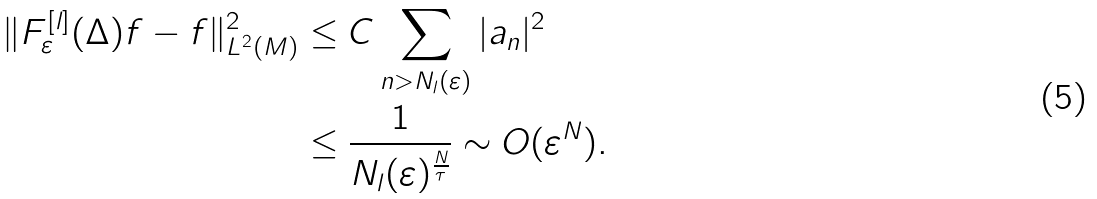<formula> <loc_0><loc_0><loc_500><loc_500>\| F ^ { [ l ] } _ { \varepsilon } ( \Delta ) f - f \| _ { L ^ { 2 } ( M ) } ^ { 2 } & \leq C \sum _ { n > N _ { l } ( \varepsilon ) } | a _ { n } | ^ { 2 } \\ & \leq \frac { 1 } { N _ { l } ( \varepsilon ) ^ { \frac { N } { \tau } } } \sim O ( \varepsilon ^ { N } ) .</formula> 